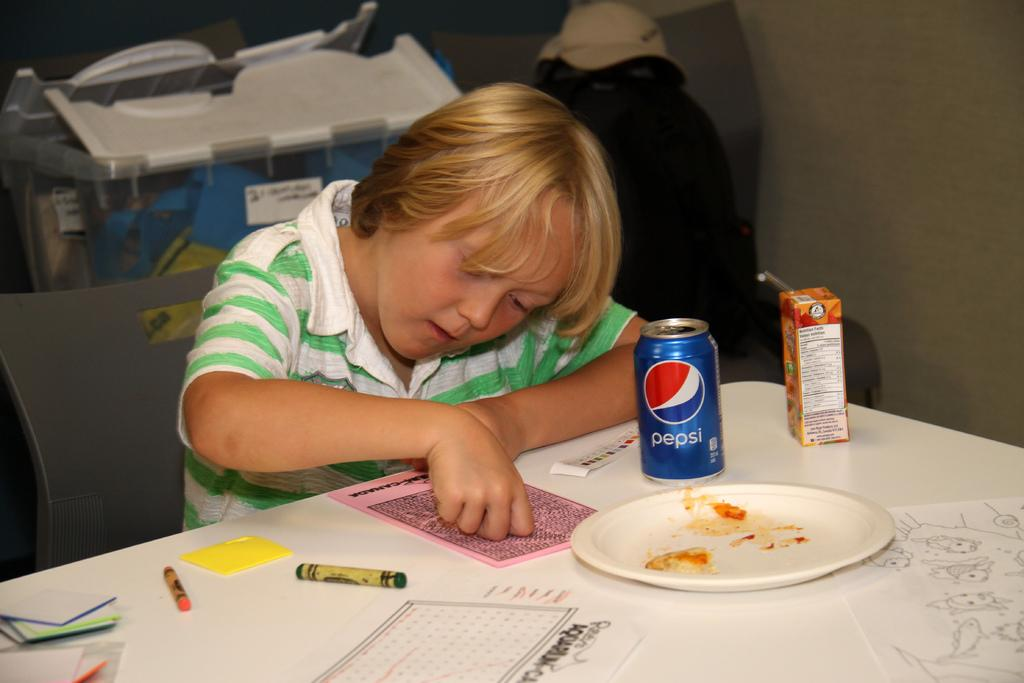<image>
Describe the image concisely. A blue can of Pepsi is on a table, next to a kid. 